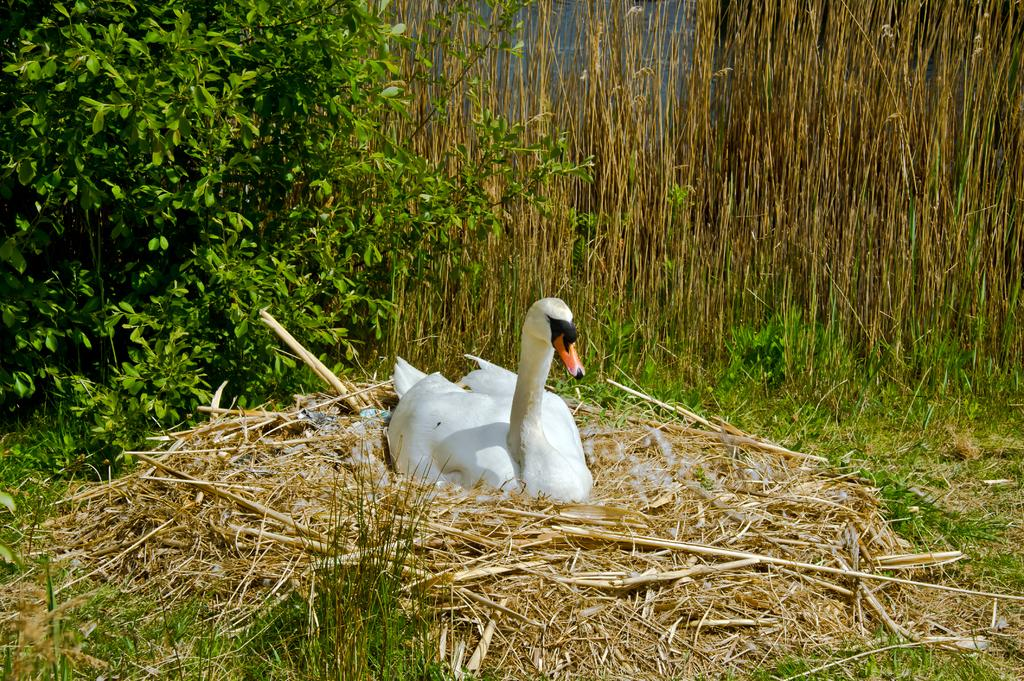What type of animal is in the image? There is a swan in the image. What type of terrain is visible in the image? There is grass visible in the image. What can be seen in the background of the image? There are plants in the background of the image. What type of shop can be seen in the background of the image? There is no shop present in the image; it features a swan in a grassy area with plants in the background. 